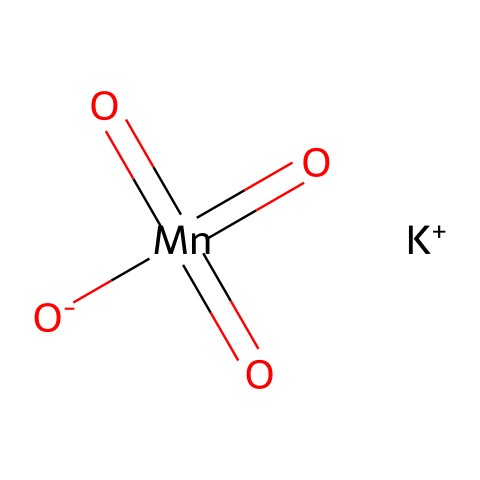What is the oxidation state of manganese in this compound? The oxidation state of manganese can be determined by considering the overall charge of the molecule and the contributions from other elements. Potassium has a +1 charge, and the four oxygen atoms (one of which has a -1 charge and three of which are in double bonds contributing a -2 total) combine to contribute a -2 charge. Therefore, for the compound to be neutral, manganese must be in the +7 oxidation state.
Answer: +7 How many oxygen atoms are present in the structure? By examining the SMILES representation, we can see that there are four oxygen atoms included, as denoted by the "O" characters in the structure. Each "O" indicates one oxygen atom.
Answer: 4 What is the total number of atoms in this molecule? To calculate the total number of atoms, we add the number of potassium (1), manganese (1), and oxygen (4) atoms together. Therefore, the total is 1 + 1 + 4 = 6 atoms.
Answer: 6 Is potassium permanganate an acid, base, or oxidizer? Potassium permanganate is known for its strong oxidizing properties, especially due to the presence of manganese in a high oxidation state (+7). It reacts with reducing agents and thus is classified as an oxidizer.
Answer: oxidizer What is the main use of potassium permanganate? Potassium permanganate is commonly used as an oxidizing agent in various applications, particularly in water treatment processes for wastewater purification, where it helps to oxidize pollutants and organic matter.
Answer: wastewater purification 